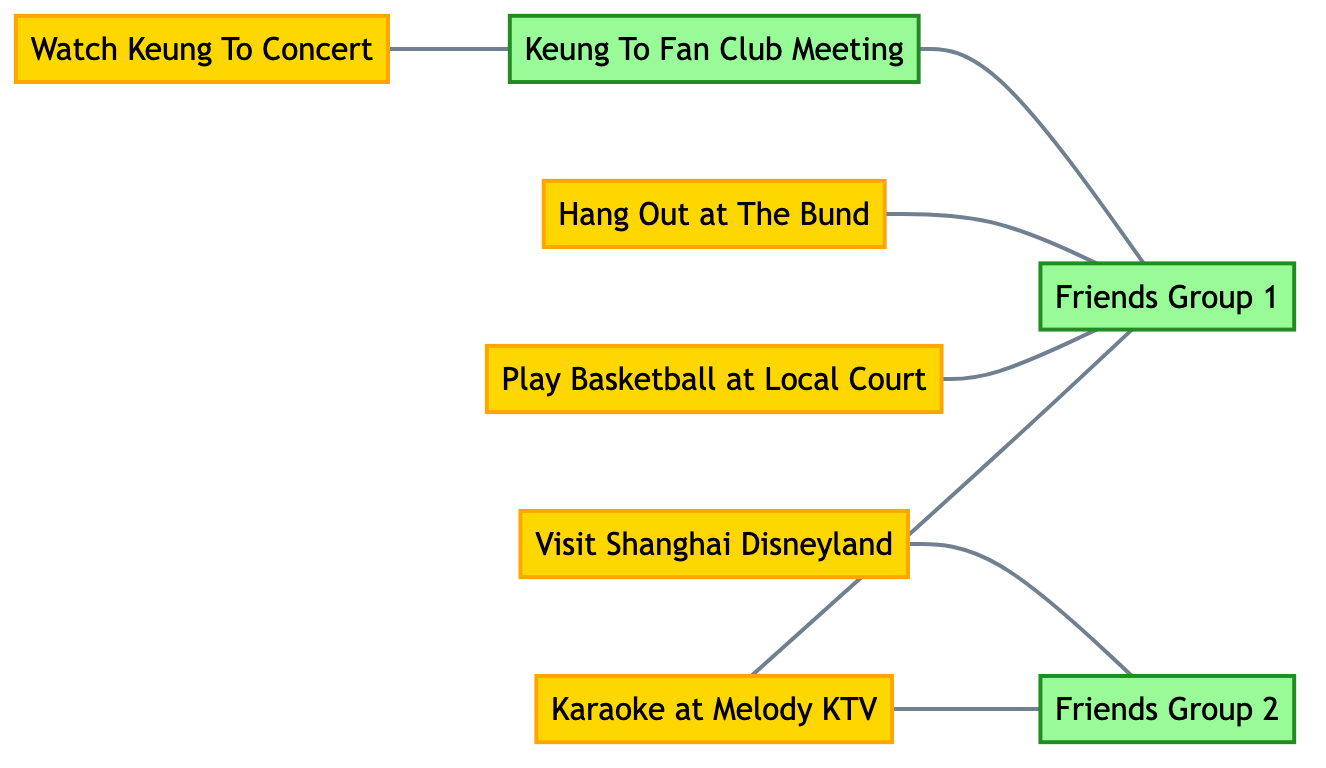What is the total number of activities represented in the graph? The graph includes activities represented by nodes, which are "Watch Keung To Concert," "Karaoke at Melody KTV," "Play Basketball at Local Court," "Hang Out at The Bund," and "Visit Shanghai Disneyland." Counting these gives a total of 5 activities.
Answer: 5 Which group is connected to "Watch Keung To Concert"? The edge from the "Watch Keung To Concert" node connects it to the "Keung To Fan Club Meeting" node, making it the only group connected to this activity.
Answer: Keung To Fan Club Meeting How many groups are associated with "Karaoke at Melody KTV"? The "Karaoke at Melody KTV" activity node is connected to two group nodes, "Friends Group 1" and "Friends Group 2," indicating that it is associated with both groups.
Answer: 2 Which activities are linked to "Friends Group 1"? The "Friends Group 1" is connected to the "Karaoke at Melody KTV," "Play Basketball at Local Court," and "Hang Out at The Bund" activity nodes. By counting these connections, we find that three activities are linked to this group.
Answer: 3 Is there a direct connection between "Keung To Fan Club Meeting" and "Visit Shanghai Disneyland"? The "Keung To Fan Club Meeting" does not have a direct edge or link to the "Visit Shanghai Disneyland" activity node as per the edges described; hence, there is no direct connection between them.
Answer: No Which activity has the most connections to different groups? The "Karaoke at Melody KTV" activity connects to two groups: "Friends Group 1" and "Friends Group 2." Since no other activity connects to more than one group, it has the most connections.
Answer: Karaoke at Melody KTV How many edges are there in total? Counting the connections (or edges) represented in the graph, we find seven edges that connect the various activities and groups.
Answer: 7 Which two activities are exclusively associated with "Friends Group 2"? Only "Karaoke at Melody KTV" and "Visit Shanghai Disneyland" activities have edges that connect exclusively to "Friends Group 2." By identifying the edges, we can confirm that these activities are the only ones linked to the group in question.
Answer: Karaoke at Melody KTV, Visit Shanghai Disneyland 